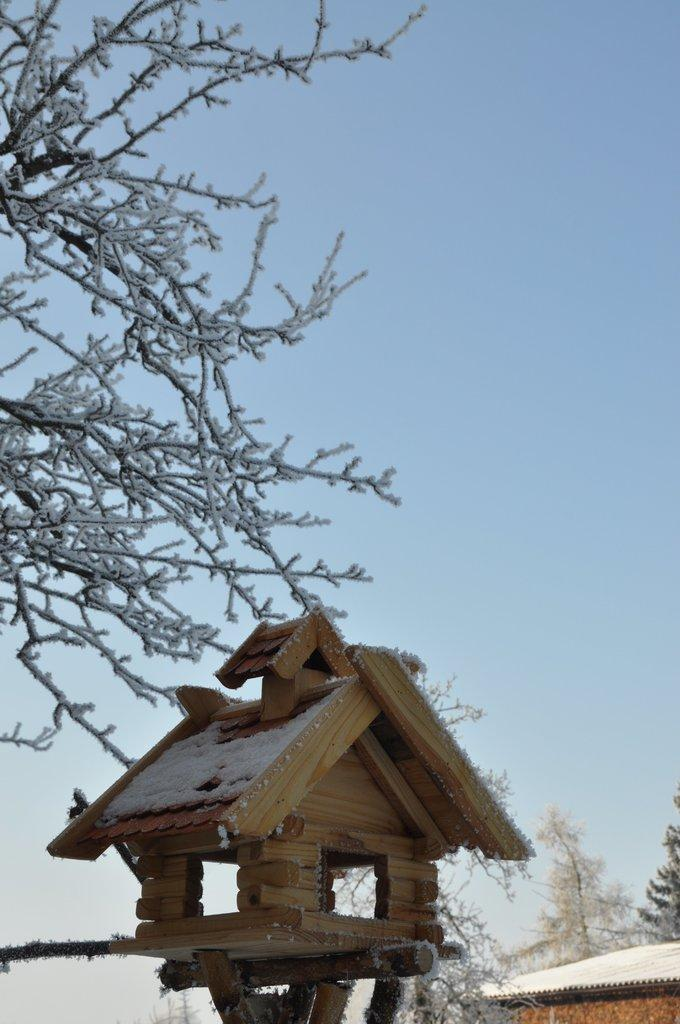What type of structure is in the image? There is a small house in the image. What material is the house made of? The house is made of wood. How far away is the tank from the house in the image? There is no tank present in the image, so it is not possible to determine the distance between the house and a tank. 